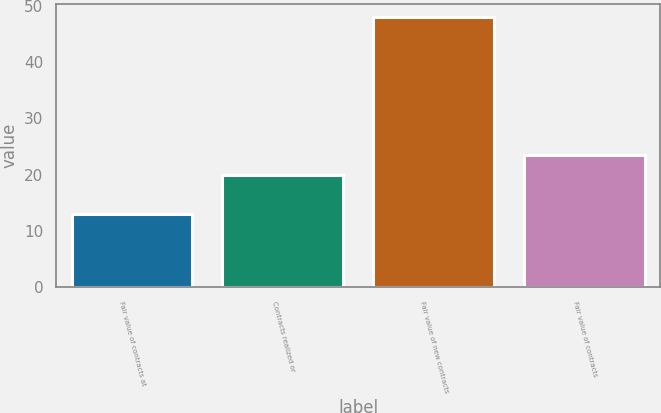Convert chart. <chart><loc_0><loc_0><loc_500><loc_500><bar_chart><fcel>Fair value of contracts at<fcel>Contracts realized or<fcel>Fair value of new contracts<fcel>Fair value of contracts<nl><fcel>13<fcel>20<fcel>48<fcel>23.5<nl></chart> 